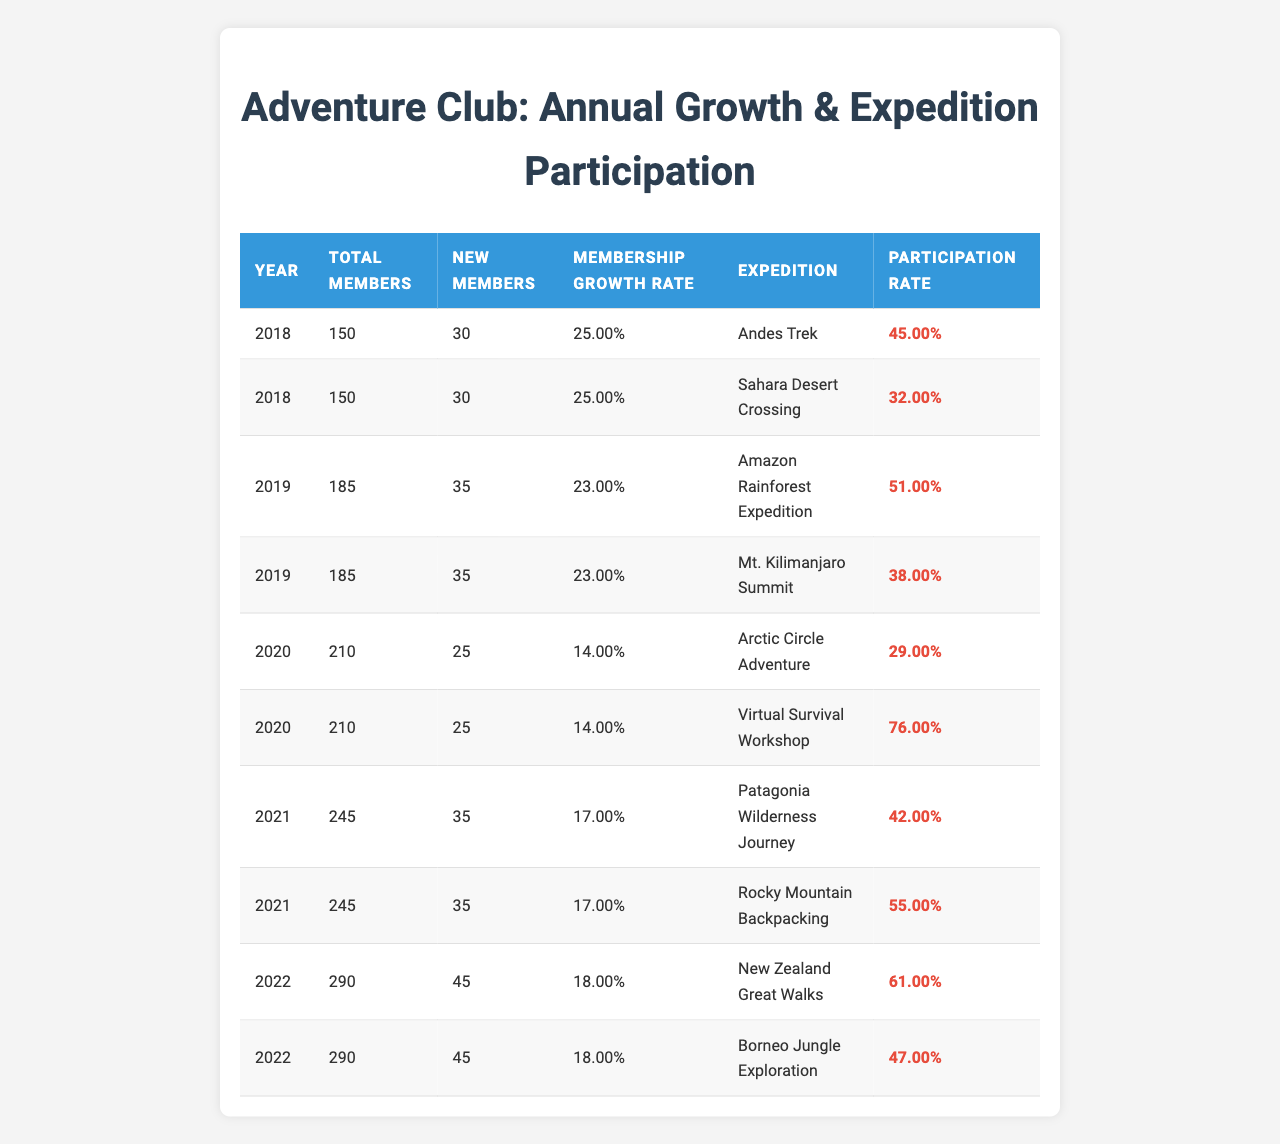What was the membership growth rate in 2021? The membership growth rate for 2021 is listed in the table, where it shows 0.17 (or 17%) in that year's row.
Answer: 0.17 How many total members were there in 2020? According to the table, the total number of members in 2020 is listed as 210.
Answer: 210 What is the percentage of new members in 2019 compared to the total members that year? In 2019, there were 35 new members out of 185 total members. To find the percentage, use the formula (new members/total members) * 100, so (35/185)*100 ≈ 18.92%.
Answer: 18.92% Which expedition in 2022 had the highest participation rate? Looking at the participation rates for expeditions in 2022, "New Zealand Great Walks" has a participation rate of 61%, which is higher than the 47% participation rate for "Borneo Jungle Exploration".
Answer: New Zealand Great Walks What was the average participation rate across all expeditions in 2020? The participation rates for 2020 are 29% for "Arctic Circle Adventure" and 76% for "Virtual Survival Workshop". To find the average, calculate (29 + 76) / 2 = 52.5%.
Answer: 52.5% Did the adventure club experience an increase in participation rate from 2018 to 2021? In 2018, the maximum participation rate was 0.45, while in 2021, the maximum was 0.55. Since 0.55 > 0.45, there was an increase in participation rate.
Answer: Yes What is the difference in total members between 2018 and 2022? The total number of members in 2018 was 150, and in 2022 it was 290. The difference is calculated as 290 - 150 = 140 members.
Answer: 140 How did the membership growth rate change from 2019 to 2020? The membership growth rate in 2019 was 0.23 (23%) and in 2020 it decreased to 0.14 (14%). The change is therefore 0.14 - 0.23 = -0.09, indicating a decrease.
Answer: Decrease Which year had the highest number of new members? When reviewing the data, the year with the highest count of new members is 2022, with 45 new members.
Answer: 2022 What expedition had a participation rate above 70%? The "Virtual Survival Workshop" in 2020 had a participation rate of 76%, which is above 70%.
Answer: Virtual Survival Workshop 